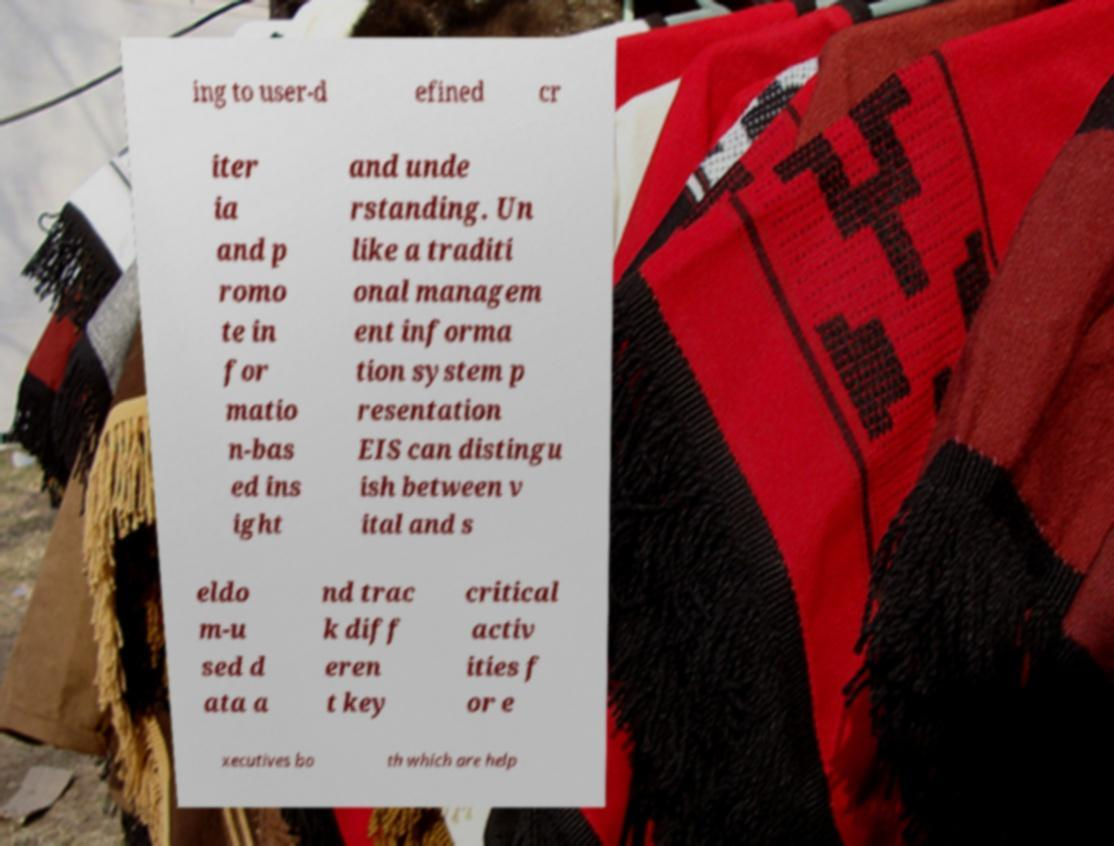Can you read and provide the text displayed in the image?This photo seems to have some interesting text. Can you extract and type it out for me? ing to user-d efined cr iter ia and p romo te in for matio n-bas ed ins ight and unde rstanding. Un like a traditi onal managem ent informa tion system p resentation EIS can distingu ish between v ital and s eldo m-u sed d ata a nd trac k diff eren t key critical activ ities f or e xecutives bo th which are help 